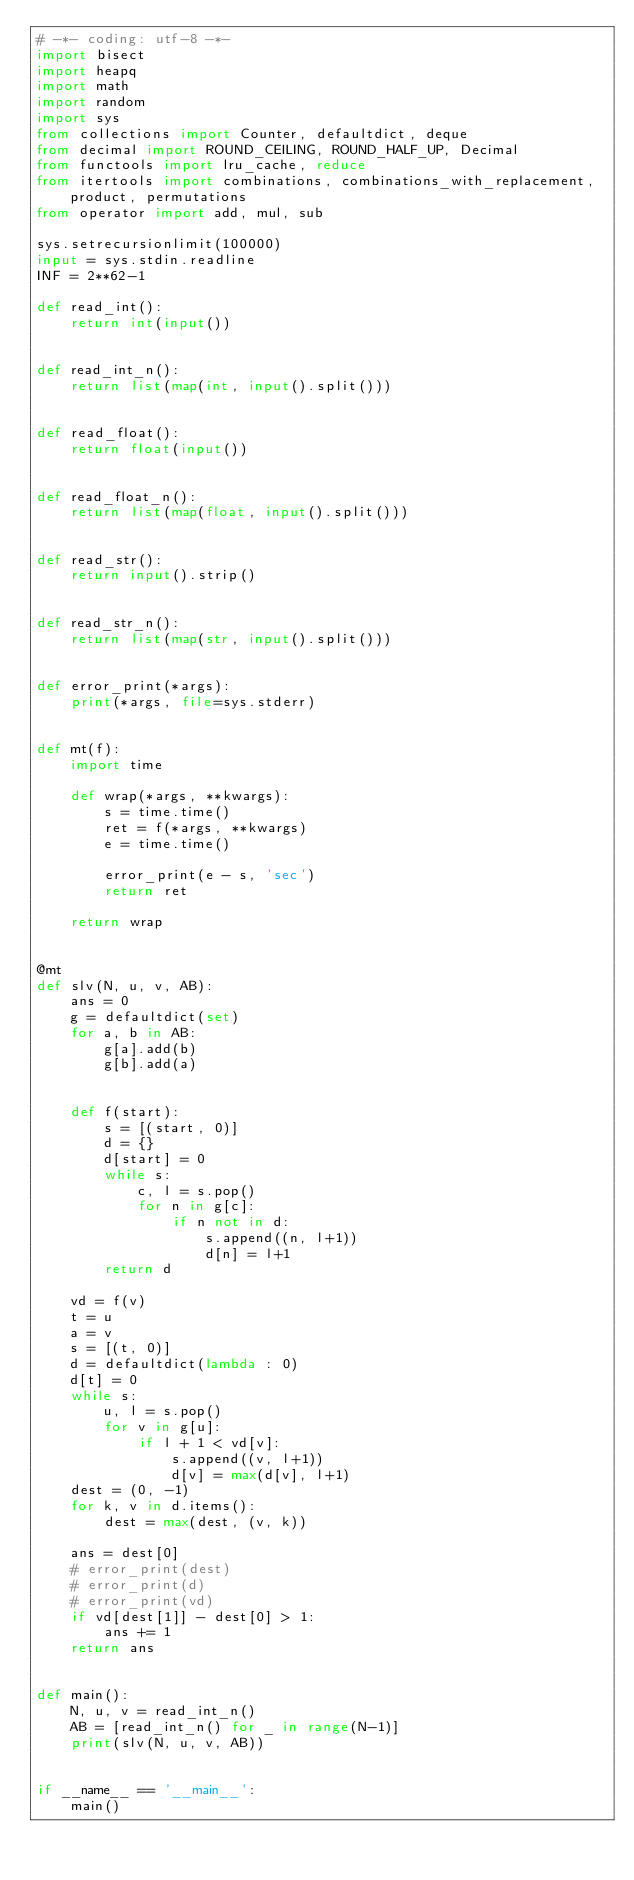<code> <loc_0><loc_0><loc_500><loc_500><_Python_># -*- coding: utf-8 -*-
import bisect
import heapq
import math
import random
import sys
from collections import Counter, defaultdict, deque
from decimal import ROUND_CEILING, ROUND_HALF_UP, Decimal
from functools import lru_cache, reduce
from itertools import combinations, combinations_with_replacement, product, permutations
from operator import add, mul, sub

sys.setrecursionlimit(100000)
input = sys.stdin.readline
INF = 2**62-1

def read_int():
    return int(input())


def read_int_n():
    return list(map(int, input().split()))


def read_float():
    return float(input())


def read_float_n():
    return list(map(float, input().split()))


def read_str():
    return input().strip()


def read_str_n():
    return list(map(str, input().split()))


def error_print(*args):
    print(*args, file=sys.stderr)


def mt(f):
    import time

    def wrap(*args, **kwargs):
        s = time.time()
        ret = f(*args, **kwargs)
        e = time.time()

        error_print(e - s, 'sec')
        return ret

    return wrap


@mt
def slv(N, u, v, AB):
    ans = 0
    g = defaultdict(set)
    for a, b in AB:
        g[a].add(b)
        g[b].add(a)


    def f(start):
        s = [(start, 0)]
        d = {}
        d[start] = 0
        while s:
            c, l = s.pop()
            for n in g[c]:
                if n not in d:
                    s.append((n, l+1))
                    d[n] = l+1
        return d

    vd = f(v)
    t = u
    a = v
    s = [(t, 0)]
    d = defaultdict(lambda : 0)
    d[t] = 0
    while s:
        u, l = s.pop()
        for v in g[u]:
            if l + 1 < vd[v]:
                s.append((v, l+1))
                d[v] = max(d[v], l+1)
    dest = (0, -1)
    for k, v in d.items():
        dest = max(dest, (v, k))

    ans = dest[0]
    # error_print(dest)
    # error_print(d)
    # error_print(vd)
    if vd[dest[1]] - dest[0] > 1:
        ans += 1
    return ans


def main():
    N, u, v = read_int_n()
    AB = [read_int_n() for _ in range(N-1)]
    print(slv(N, u, v, AB))


if __name__ == '__main__':
    main()
</code> 